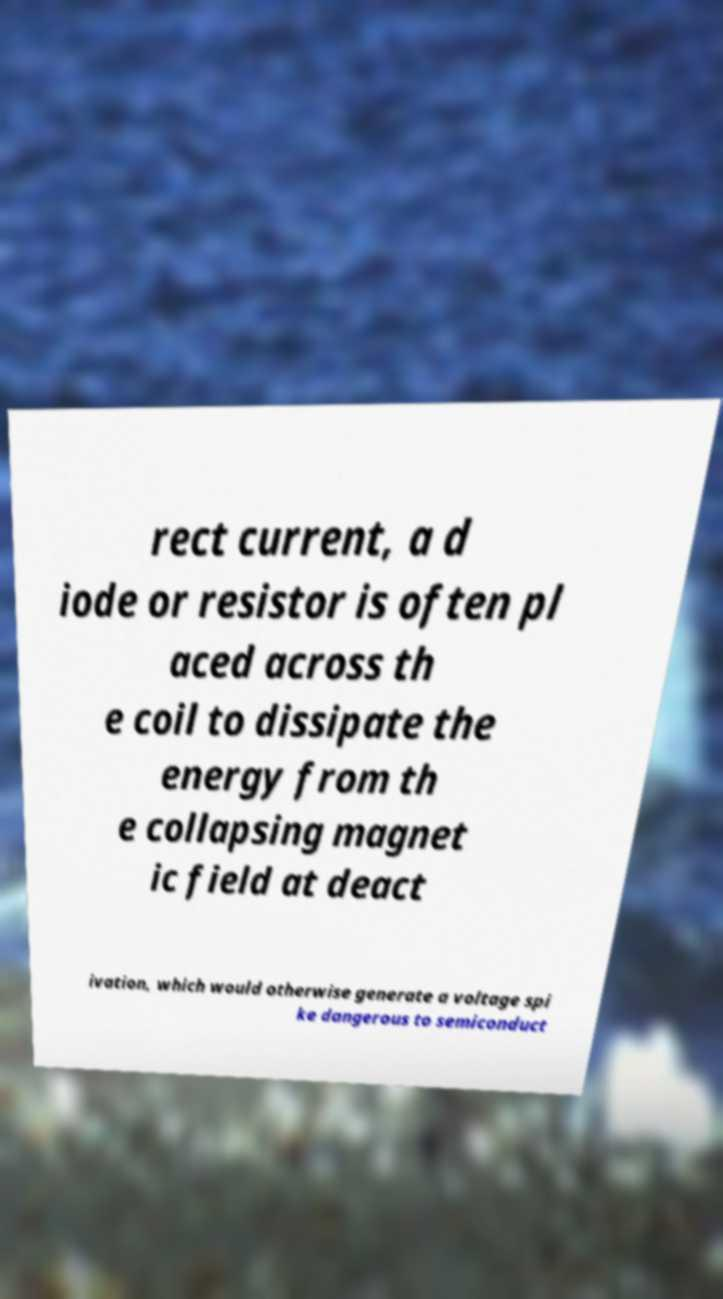Could you extract and type out the text from this image? rect current, a d iode or resistor is often pl aced across th e coil to dissipate the energy from th e collapsing magnet ic field at deact ivation, which would otherwise generate a voltage spi ke dangerous to semiconduct 